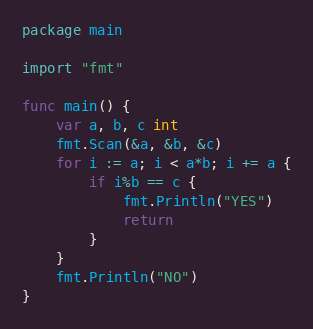Convert code to text. <code><loc_0><loc_0><loc_500><loc_500><_Go_>package main

import "fmt"

func main() {
	var a, b, c int
	fmt.Scan(&a, &b, &c)
	for i := a; i < a*b; i += a {
		if i%b == c {
			fmt.Println("YES")
			return
		}
	}
	fmt.Println("NO")
}
</code> 